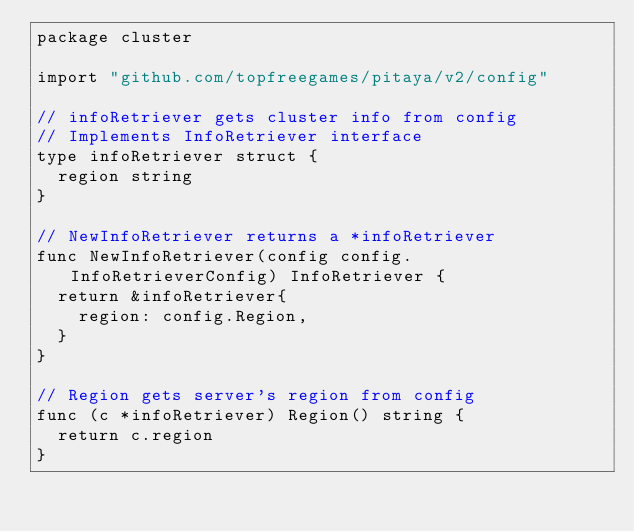<code> <loc_0><loc_0><loc_500><loc_500><_Go_>package cluster

import "github.com/topfreegames/pitaya/v2/config"

// infoRetriever gets cluster info from config
// Implements InfoRetriever interface
type infoRetriever struct {
	region string
}

// NewInfoRetriever returns a *infoRetriever
func NewInfoRetriever(config config.InfoRetrieverConfig) InfoRetriever {
	return &infoRetriever{
		region: config.Region,
	}
}

// Region gets server's region from config
func (c *infoRetriever) Region() string {
	return c.region
}
</code> 